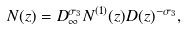Convert formula to latex. <formula><loc_0><loc_0><loc_500><loc_500>N ( z ) = D _ { \infty } ^ { \sigma _ { 3 } } N ^ { ( 1 ) } ( z ) D ( z ) ^ { - \sigma _ { 3 } } ,</formula> 